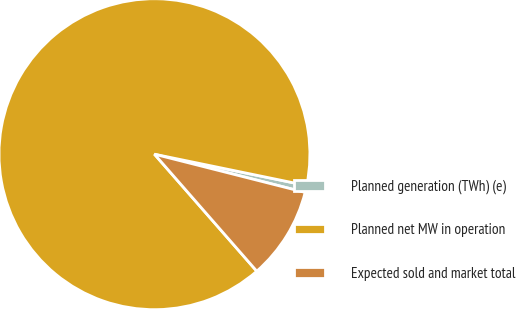<chart> <loc_0><loc_0><loc_500><loc_500><pie_chart><fcel>Planned generation (TWh) (e)<fcel>Planned net MW in operation<fcel>Expected sold and market total<nl><fcel>0.72%<fcel>89.67%<fcel>9.61%<nl></chart> 